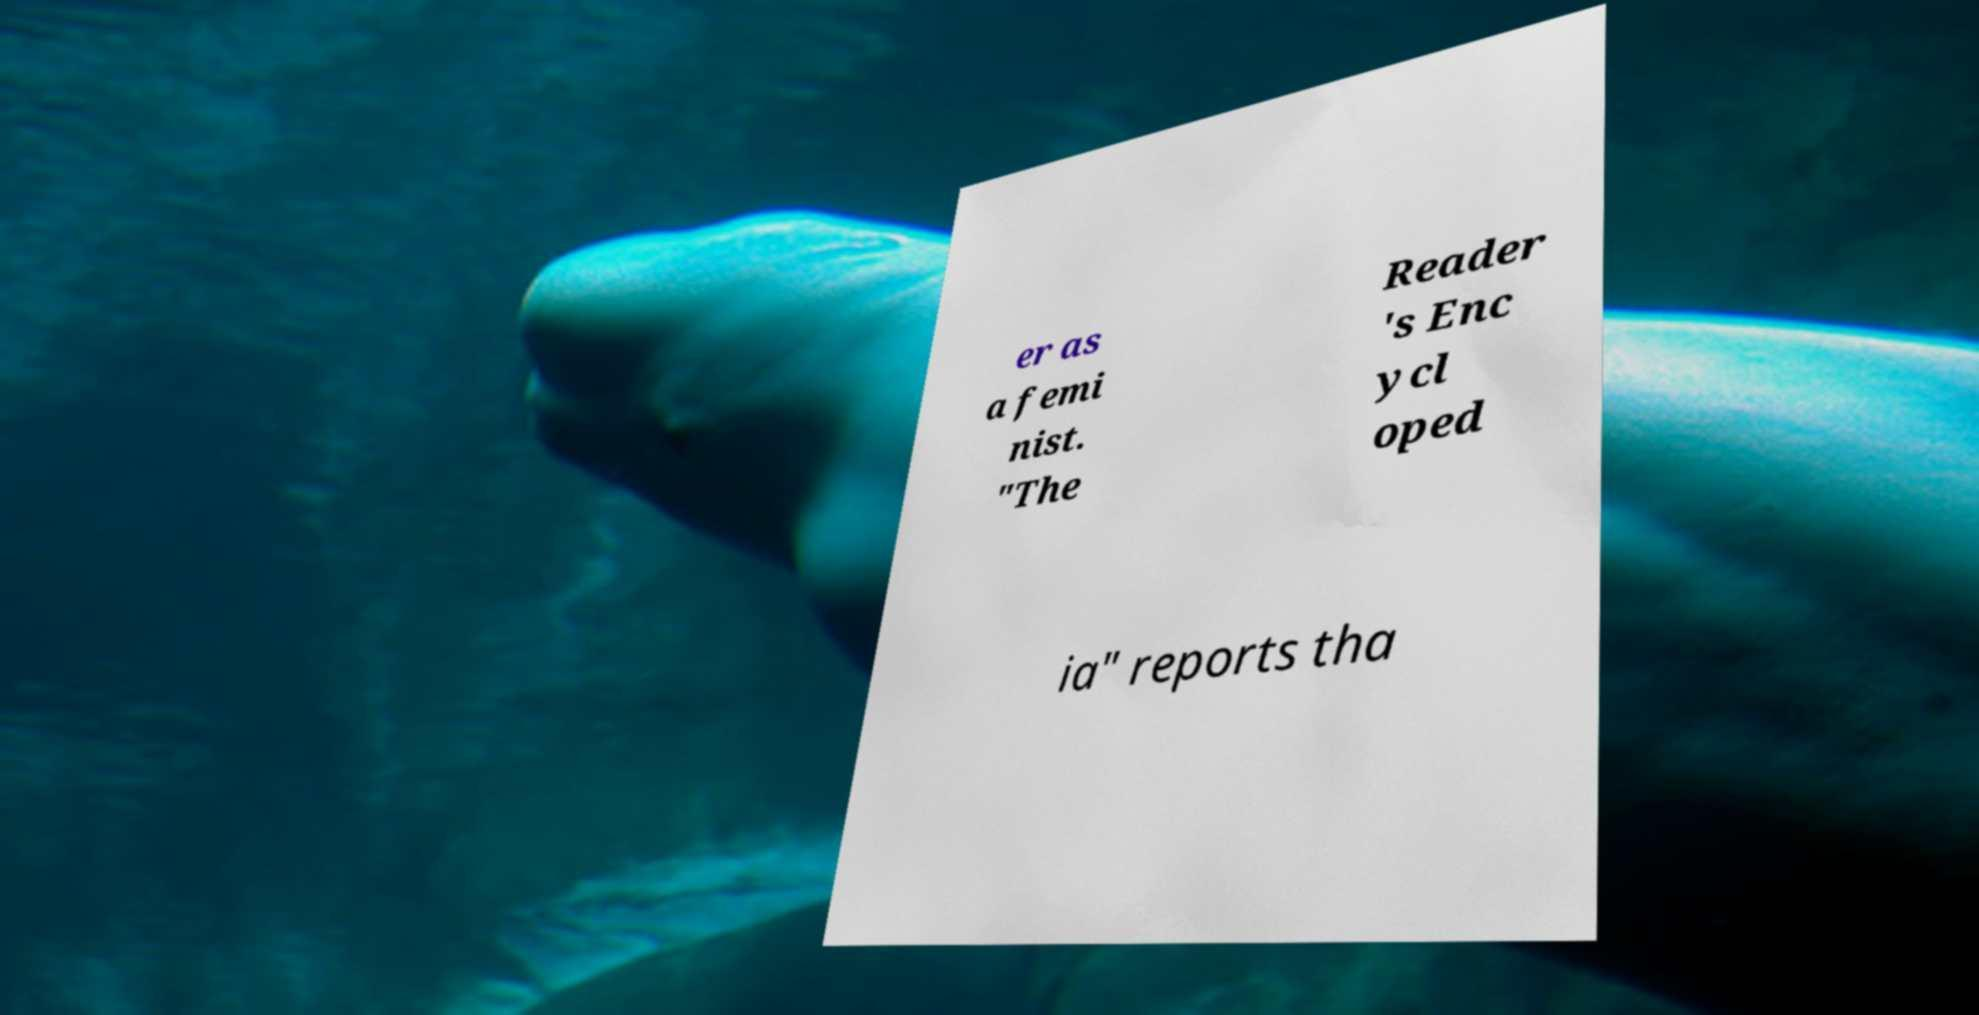Can you accurately transcribe the text from the provided image for me? er as a femi nist. "The Reader 's Enc ycl oped ia" reports tha 